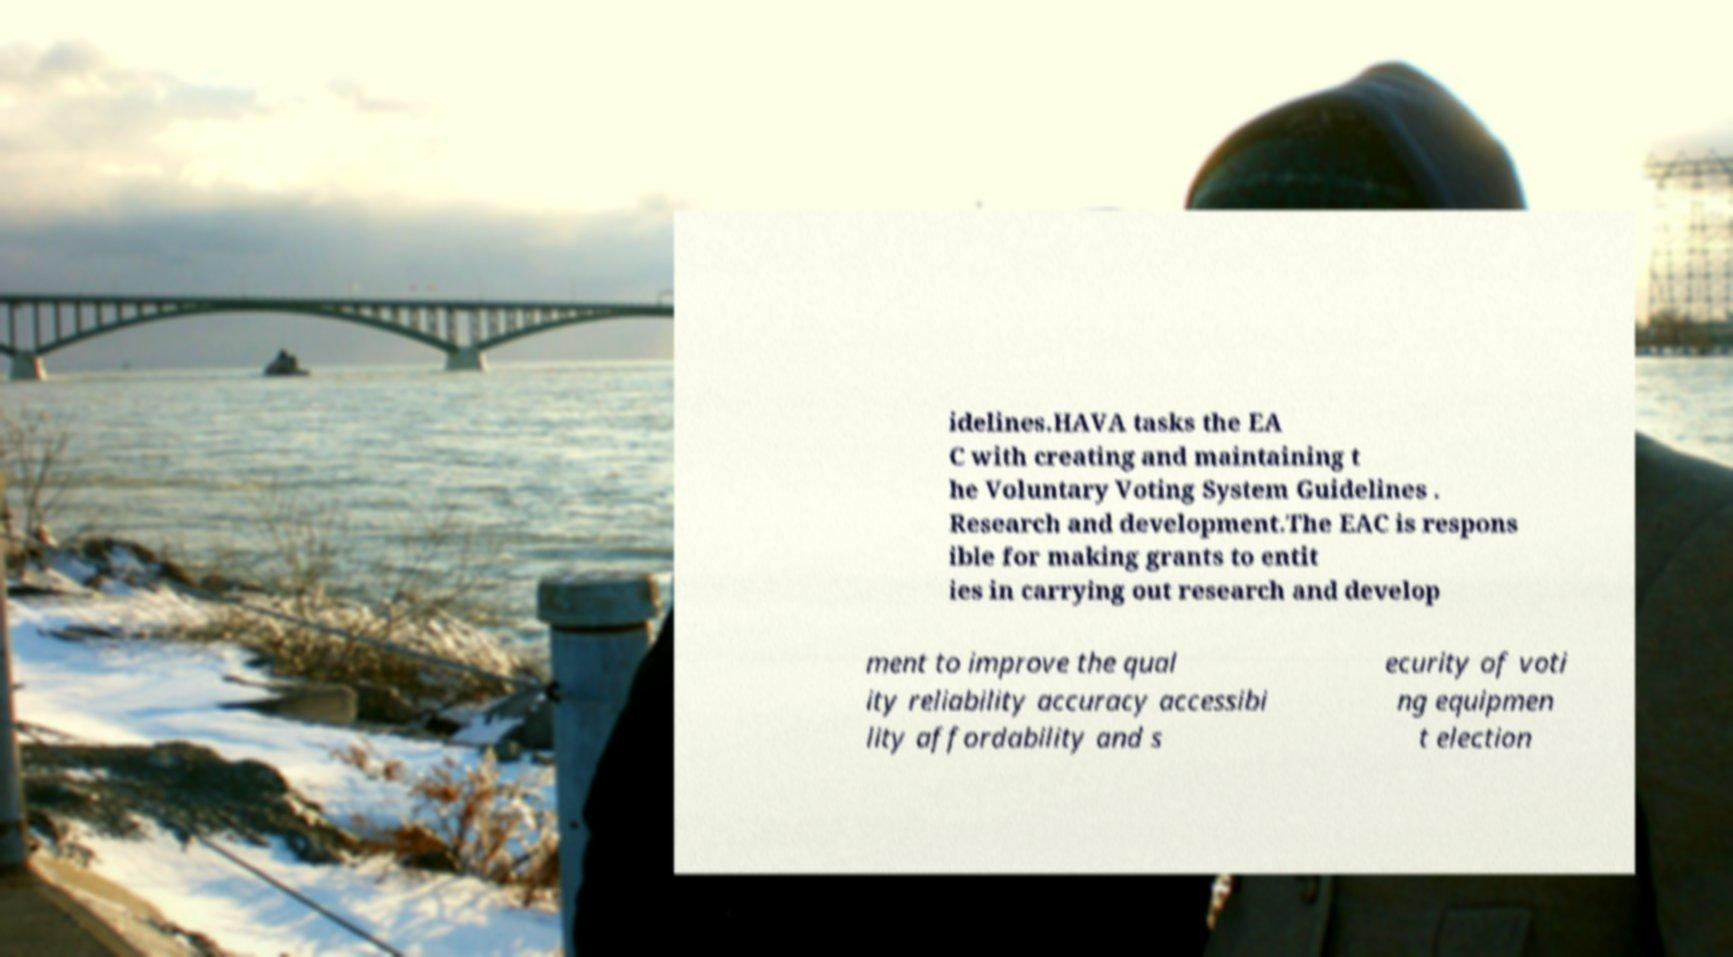Please read and relay the text visible in this image. What does it say? idelines.HAVA tasks the EA C with creating and maintaining t he Voluntary Voting System Guidelines . Research and development.The EAC is respons ible for making grants to entit ies in carrying out research and develop ment to improve the qual ity reliability accuracy accessibi lity affordability and s ecurity of voti ng equipmen t election 